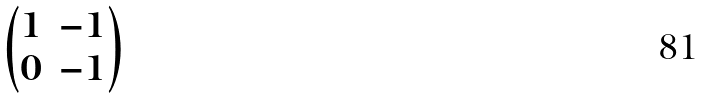Convert formula to latex. <formula><loc_0><loc_0><loc_500><loc_500>\begin{pmatrix} 1 & - 1 \\ 0 & - 1 \end{pmatrix}</formula> 